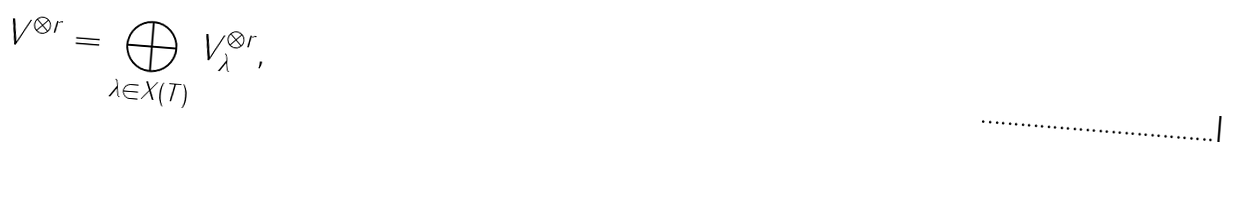<formula> <loc_0><loc_0><loc_500><loc_500>V ^ { \otimes r } = \bigoplus _ { \lambda \in X ( T ) } V ^ { \otimes r } _ { \lambda } ,</formula> 